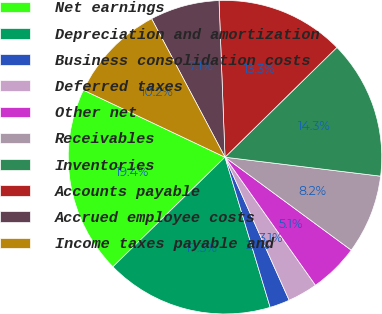<chart> <loc_0><loc_0><loc_500><loc_500><pie_chart><fcel>Net earnings<fcel>Depreciation and amortization<fcel>Business consolidation costs<fcel>Deferred taxes<fcel>Other net<fcel>Receivables<fcel>Inventories<fcel>Accounts payable<fcel>Accrued employee costs<fcel>Income taxes payable and<nl><fcel>19.37%<fcel>17.33%<fcel>2.06%<fcel>3.08%<fcel>5.11%<fcel>8.17%<fcel>14.28%<fcel>13.26%<fcel>7.15%<fcel>10.2%<nl></chart> 